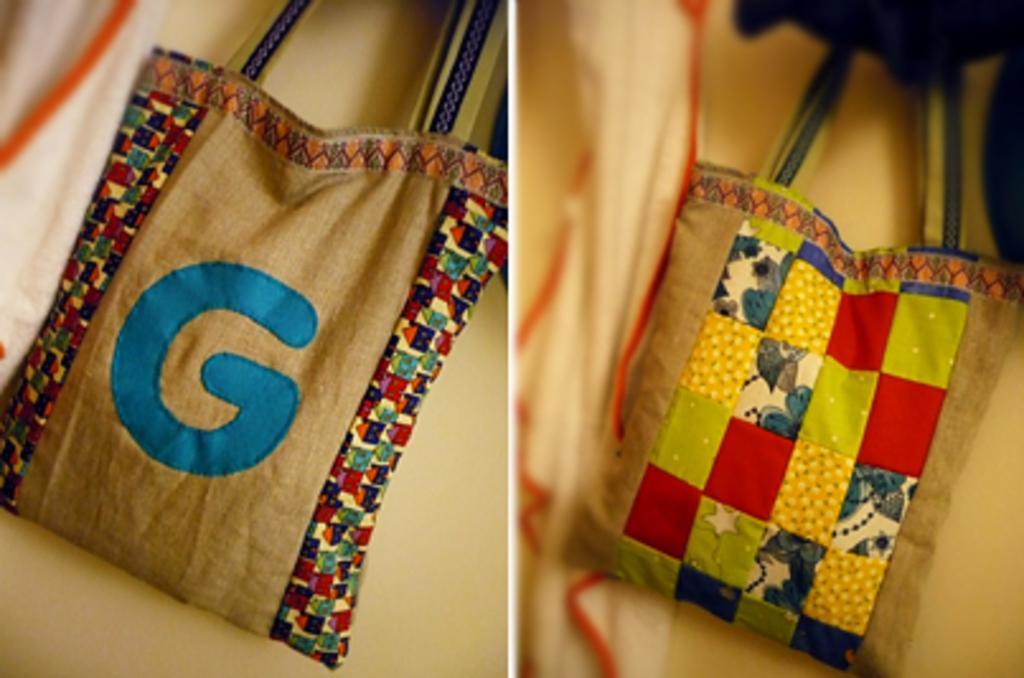How would you summarize this image in a sentence or two? There are two bags and it is a collage picture. 